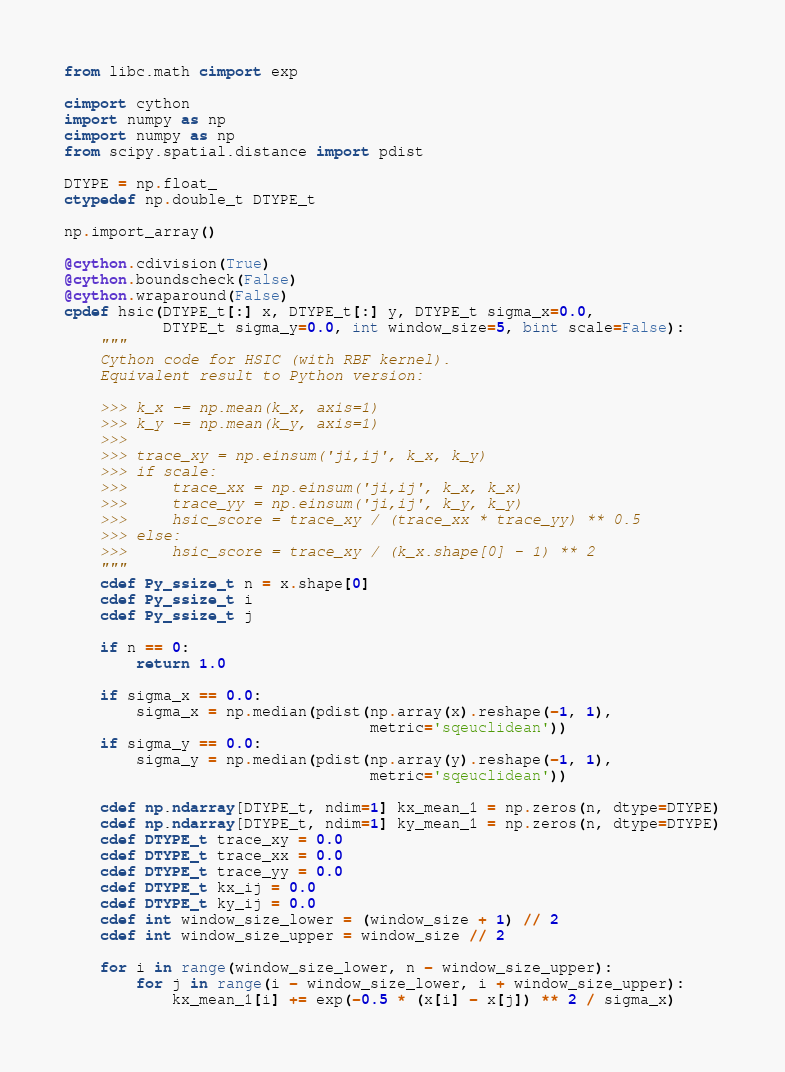<code> <loc_0><loc_0><loc_500><loc_500><_Cython_>from libc.math cimport exp

cimport cython
import numpy as np
cimport numpy as np
from scipy.spatial.distance import pdist

DTYPE = np.float_
ctypedef np.double_t DTYPE_t

np.import_array()

@cython.cdivision(True)
@cython.boundscheck(False)
@cython.wraparound(False)
cpdef hsic(DTYPE_t[:] x, DTYPE_t[:] y, DTYPE_t sigma_x=0.0,
           DTYPE_t sigma_y=0.0, int window_size=5, bint scale=False):
    """
    Cython code for HSIC (with RBF kernel).
    Equivalent result to Python version:

    >>> k_x -= np.mean(k_x, axis=1)
    >>> k_y -= np.mean(k_y, axis=1)
    >>>
    >>> trace_xy = np.einsum('ji,ij', k_x, k_y)
    >>> if scale:
    >>>     trace_xx = np.einsum('ji,ij', k_x, k_x)
    >>>     trace_yy = np.einsum('ji,ij', k_y, k_y)
    >>>     hsic_score = trace_xy / (trace_xx * trace_yy) ** 0.5
    >>> else:
    >>>     hsic_score = trace_xy / (k_x.shape[0] - 1) ** 2
    """
    cdef Py_ssize_t n = x.shape[0]
    cdef Py_ssize_t i
    cdef Py_ssize_t j

    if n == 0:
        return 1.0

    if sigma_x == 0.0:
        sigma_x = np.median(pdist(np.array(x).reshape(-1, 1),
                                  metric='sqeuclidean'))
    if sigma_y == 0.0:
        sigma_y = np.median(pdist(np.array(y).reshape(-1, 1),
                                  metric='sqeuclidean'))

    cdef np.ndarray[DTYPE_t, ndim=1] kx_mean_1 = np.zeros(n, dtype=DTYPE)
    cdef np.ndarray[DTYPE_t, ndim=1] ky_mean_1 = np.zeros(n, dtype=DTYPE)
    cdef DTYPE_t trace_xy = 0.0
    cdef DTYPE_t trace_xx = 0.0
    cdef DTYPE_t trace_yy = 0.0
    cdef DTYPE_t kx_ij = 0.0
    cdef DTYPE_t ky_ij = 0.0
    cdef int window_size_lower = (window_size + 1) // 2
    cdef int window_size_upper = window_size // 2

    for i in range(window_size_lower, n - window_size_upper):
        for j in range(i - window_size_lower, i + window_size_upper):
            kx_mean_1[i] += exp(-0.5 * (x[i] - x[j]) ** 2 / sigma_x)</code> 